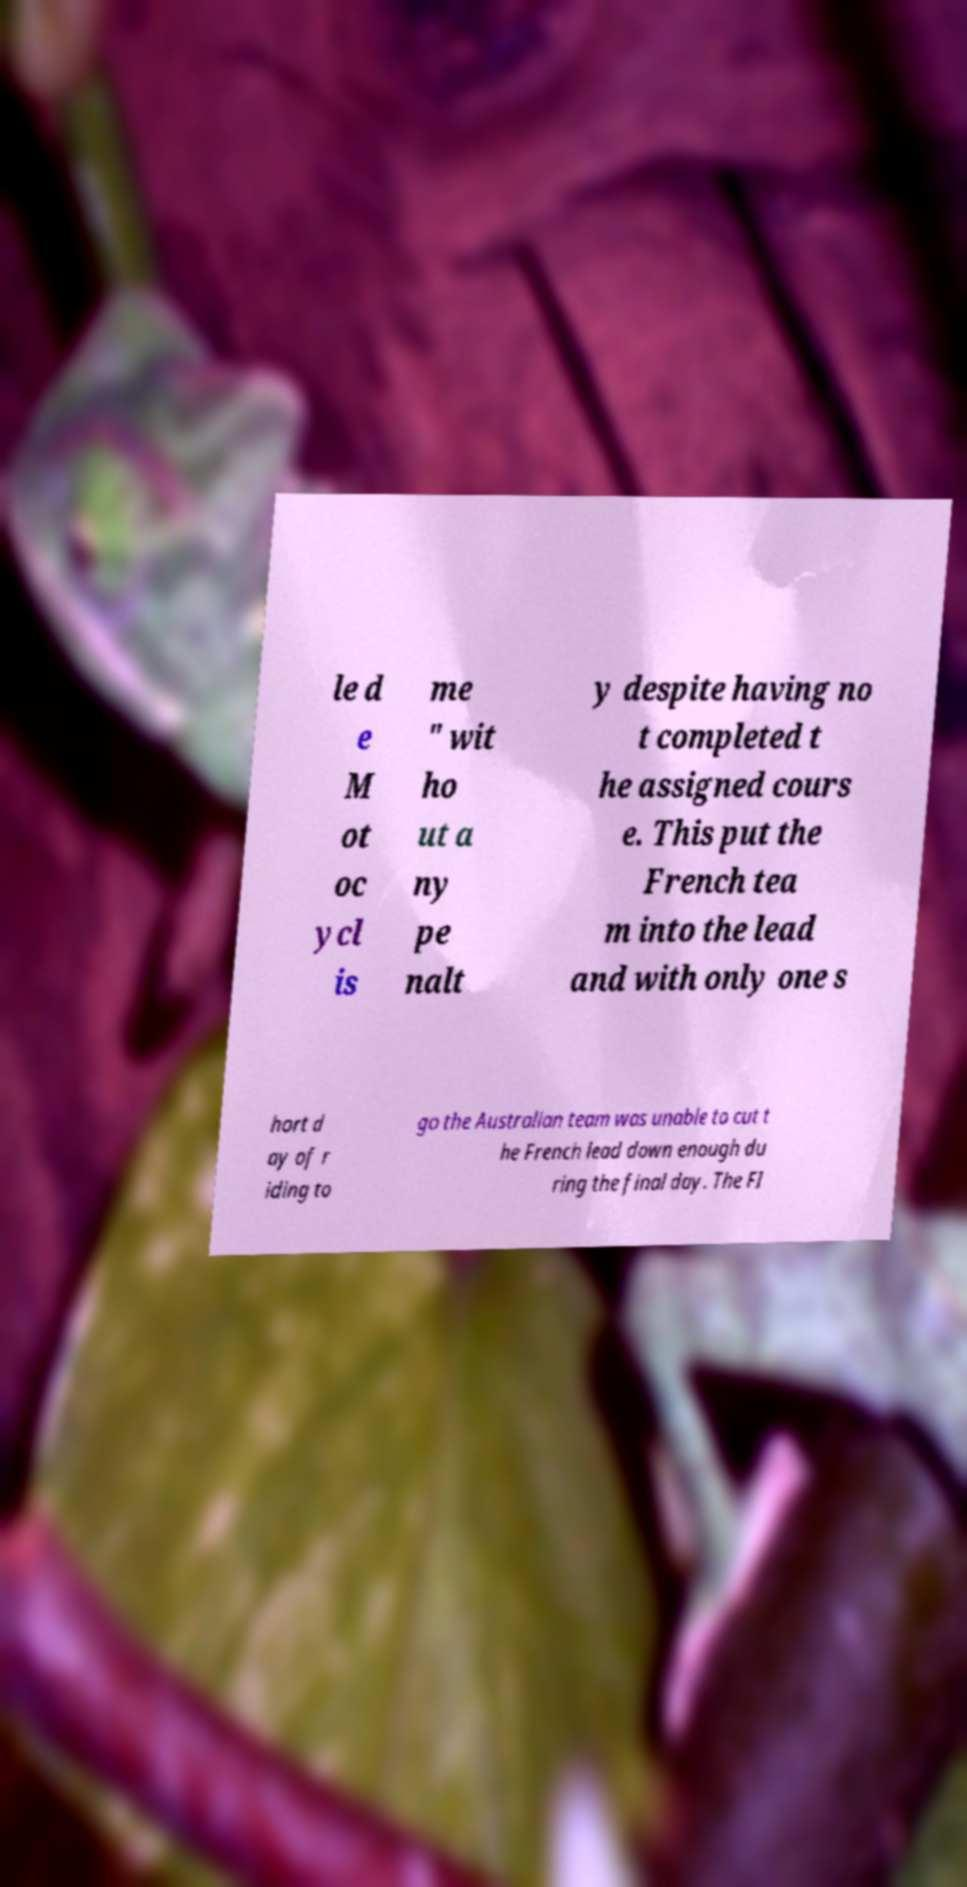Could you assist in decoding the text presented in this image and type it out clearly? le d e M ot oc ycl is me " wit ho ut a ny pe nalt y despite having no t completed t he assigned cours e. This put the French tea m into the lead and with only one s hort d ay of r iding to go the Australian team was unable to cut t he French lead down enough du ring the final day. The FI 